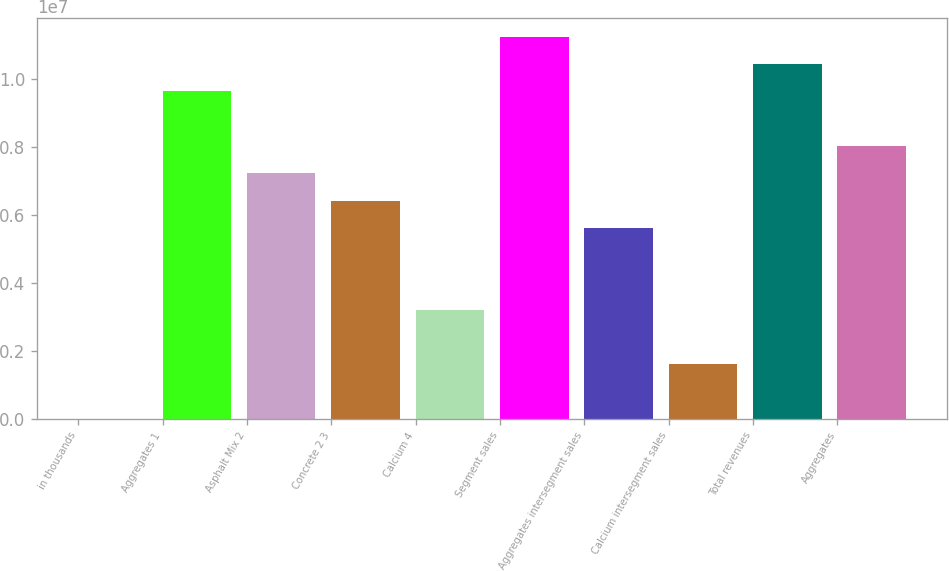Convert chart to OTSL. <chart><loc_0><loc_0><loc_500><loc_500><bar_chart><fcel>in thousands<fcel>Aggregates 1<fcel>Asphalt Mix 2<fcel>Concrete 2 3<fcel>Calcium 4<fcel>Segment sales<fcel>Aggregates intersegment sales<fcel>Calcium intersegment sales<fcel>Total revenues<fcel>Aggregates<nl><fcel>2014<fcel>9.64891e+06<fcel>7.23719e+06<fcel>6.43328e+06<fcel>3.21765e+06<fcel>1.12567e+07<fcel>5.62937e+06<fcel>1.60983e+06<fcel>1.04528e+07<fcel>8.0411e+06<nl></chart> 